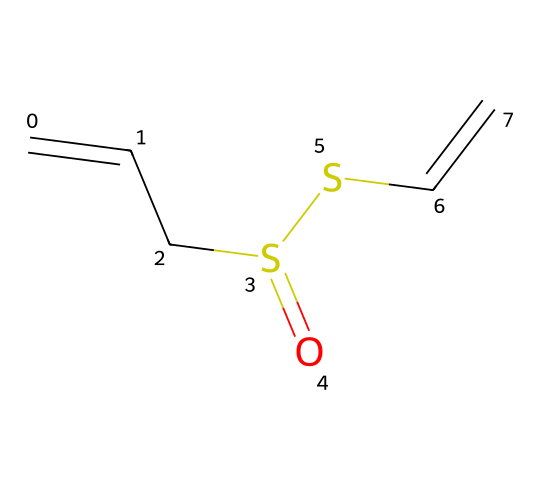What is the molecular formula of allicin? To find the molecular formula, we count the number of each type of atom present in the SMILES representation. In this case, there are 6 carbon (C) atoms, 10 hydrogen (H) atoms, 2 sulfur (S) atoms, and 1 oxygen (O) atom. Therefore, the molecular formula is C6H10O2S2.
Answer: C6H10O2S2 How many double bonds are present in allicin? By analyzing the SMILES representation, we can identify which bonds are double bonds. The representation shows two double bonds in the carbon skeleton, connected by the sulfur atoms.
Answer: 2 What is the overall charge of the allicin molecule? The SMILES indicates that there are no charged atoms or groups present in the structure. Therefore, the allicin molecule is neutral, meaning it has an overall charge of zero.
Answer: 0 What type of functional groups are present in allicin? Observing the SMILES structure, we can see that allicin contains thiol (due to sulfur) and ether functional groups. This classification is derived from the presence of two sulfur atoms connected by an oxygen atom.
Answer: thiol and ether How many sulfur atoms are present in allicin? By counting the sulfur symbols (S) in the SMILES representation, we find that there are two sulfur atoms present in the structure of allicin.
Answer: 2 What role do the sulfur atoms play in allicin’s properties? The presence of sulfur atoms in allicin contributes to its organosulfur characteristics which are responsible for its distinctive odor and potential health benefits. Sulfur compounds often exhibit biological activity, including antimicrobial properties.
Answer: distinctive odor and potential health benefits 